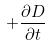Convert formula to latex. <formula><loc_0><loc_0><loc_500><loc_500>+ \frac { \partial D } { \partial t }</formula> 